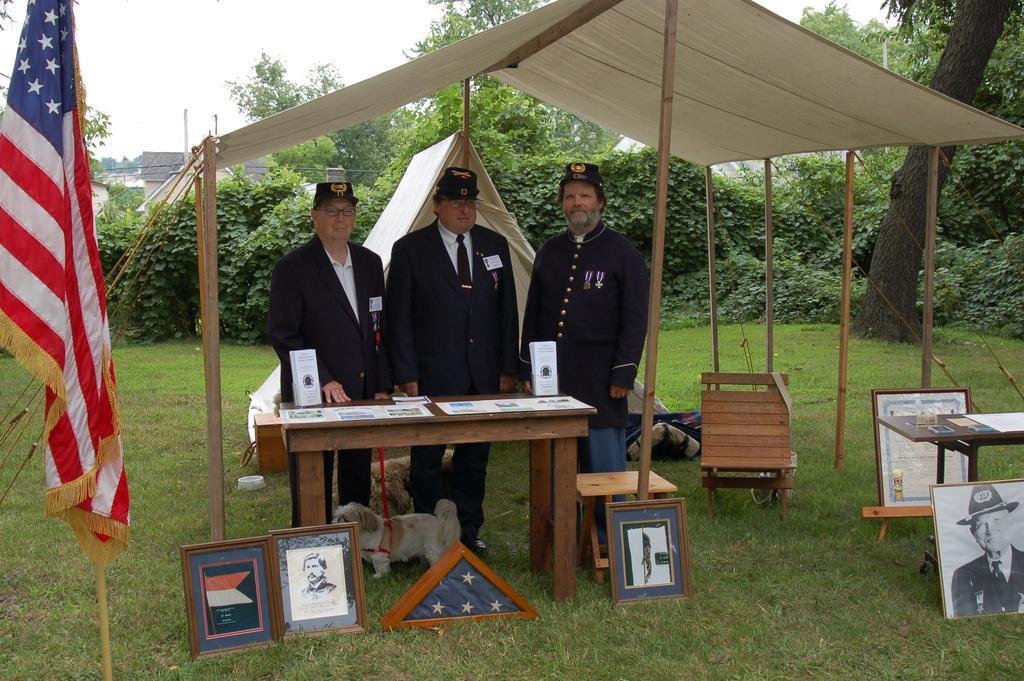Describe this image in one or two sentences. In this image we can see this people are standing near the table. We can see dogs, table, photo frames, tent, chair, flags and trees in the background. 